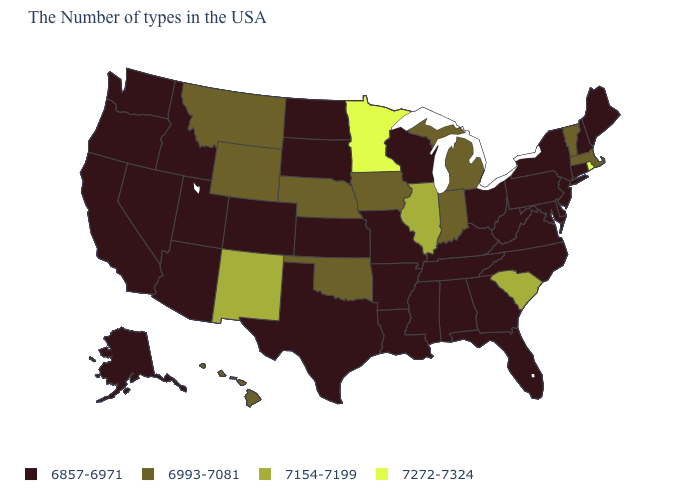Among the states that border West Virginia , which have the highest value?
Answer briefly. Maryland, Pennsylvania, Virginia, Ohio, Kentucky. Among the states that border Arkansas , which have the highest value?
Quick response, please. Oklahoma. What is the lowest value in the USA?
Write a very short answer. 6857-6971. What is the value of North Carolina?
Be succinct. 6857-6971. What is the value of Minnesota?
Answer briefly. 7272-7324. What is the value of Minnesota?
Be succinct. 7272-7324. Which states have the highest value in the USA?
Concise answer only. Rhode Island, Minnesota. Does Indiana have the same value as Kansas?
Quick response, please. No. Name the states that have a value in the range 6857-6971?
Answer briefly. Maine, New Hampshire, Connecticut, New York, New Jersey, Delaware, Maryland, Pennsylvania, Virginia, North Carolina, West Virginia, Ohio, Florida, Georgia, Kentucky, Alabama, Tennessee, Wisconsin, Mississippi, Louisiana, Missouri, Arkansas, Kansas, Texas, South Dakota, North Dakota, Colorado, Utah, Arizona, Idaho, Nevada, California, Washington, Oregon, Alaska. Name the states that have a value in the range 7272-7324?
Answer briefly. Rhode Island, Minnesota. Name the states that have a value in the range 7154-7199?
Concise answer only. South Carolina, Illinois, New Mexico. What is the value of Arkansas?
Quick response, please. 6857-6971. Does Tennessee have the same value as Arkansas?
Quick response, please. Yes. Does Ohio have a lower value than Rhode Island?
Be succinct. Yes. Does Minnesota have the highest value in the USA?
Be succinct. Yes. 